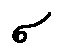<formula> <loc_0><loc_0><loc_500><loc_500>\sigma</formula> 